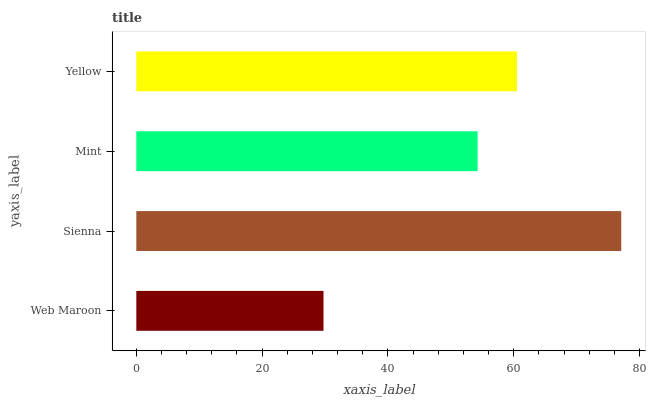Is Web Maroon the minimum?
Answer yes or no. Yes. Is Sienna the maximum?
Answer yes or no. Yes. Is Mint the minimum?
Answer yes or no. No. Is Mint the maximum?
Answer yes or no. No. Is Sienna greater than Mint?
Answer yes or no. Yes. Is Mint less than Sienna?
Answer yes or no. Yes. Is Mint greater than Sienna?
Answer yes or no. No. Is Sienna less than Mint?
Answer yes or no. No. Is Yellow the high median?
Answer yes or no. Yes. Is Mint the low median?
Answer yes or no. Yes. Is Web Maroon the high median?
Answer yes or no. No. Is Yellow the low median?
Answer yes or no. No. 